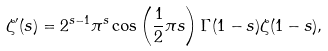Convert formula to latex. <formula><loc_0><loc_0><loc_500><loc_500>\zeta ^ { \prime } ( s ) = 2 ^ { s - 1 } \pi ^ { s } \cos \left ( \frac { 1 } { 2 } \pi s \right ) \Gamma ( 1 - s ) \zeta ( 1 - s ) ,</formula> 